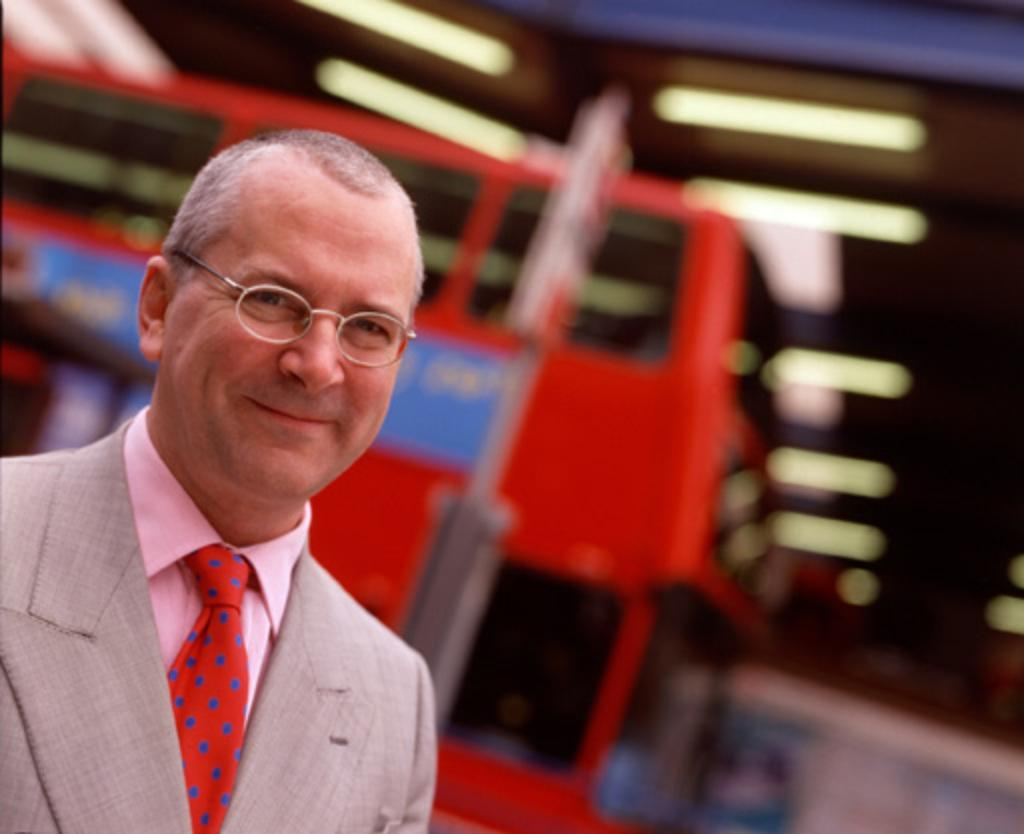Who is in the image? There is a man in the image. What is the man doing in the image? The man is smiling in the image. What can be seen in the background of the image? There are electric lights, advertisements on a pole, and a motor vehicle in the background of the image. How many parcels can be seen on the train in the image? There is no train present in the image, so it is not possible to determine the number of parcels. 